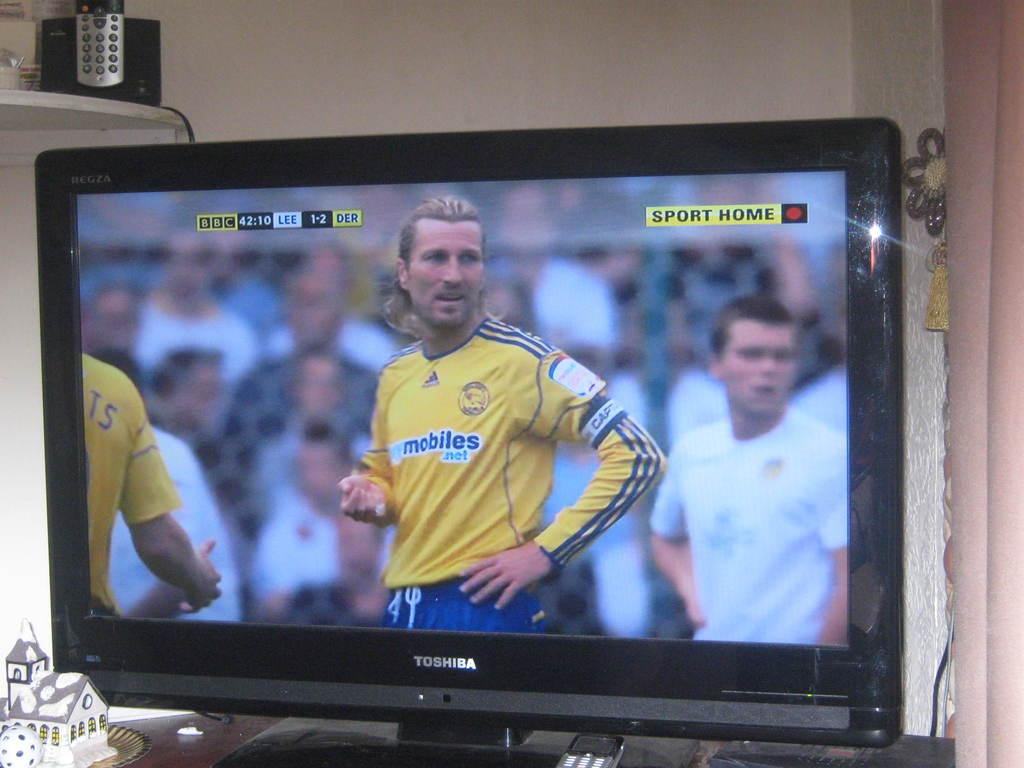<image>
Create a compact narrative representing the image presented. A tv screen shows players wearing a jersey that reads mobiles. 